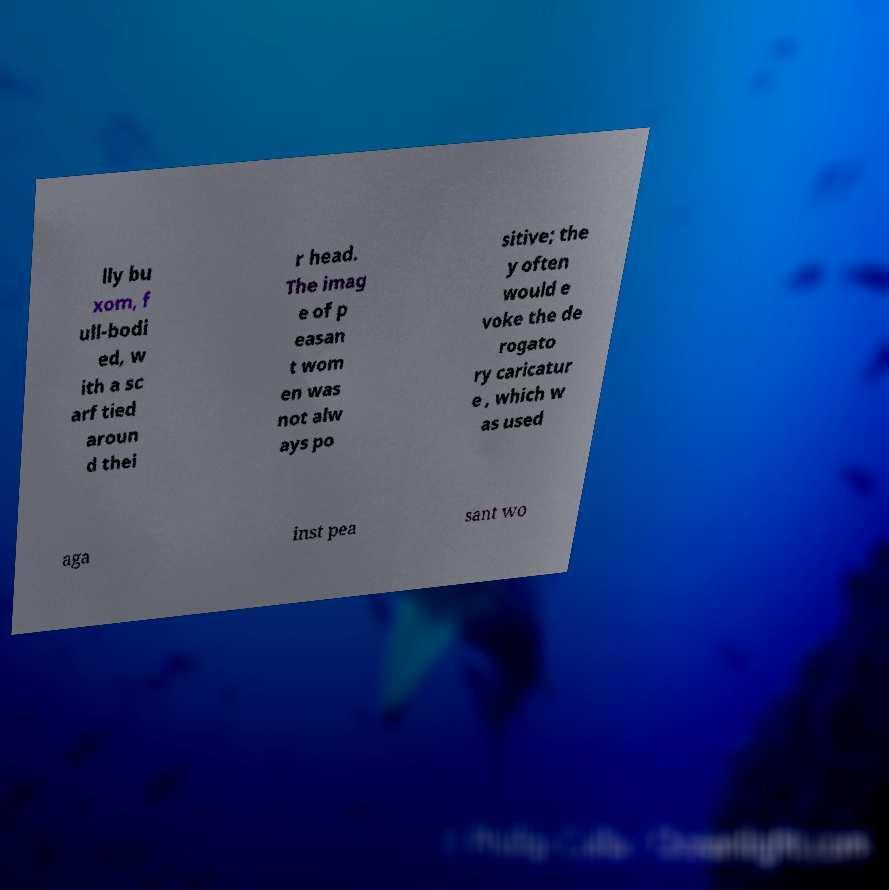Could you extract and type out the text from this image? lly bu xom, f ull-bodi ed, w ith a sc arf tied aroun d thei r head. The imag e of p easan t wom en was not alw ays po sitive; the y often would e voke the de rogato ry caricatur e , which w as used aga inst pea sant wo 